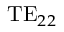<formula> <loc_0><loc_0><loc_500><loc_500>T E _ { 2 2 }</formula> 